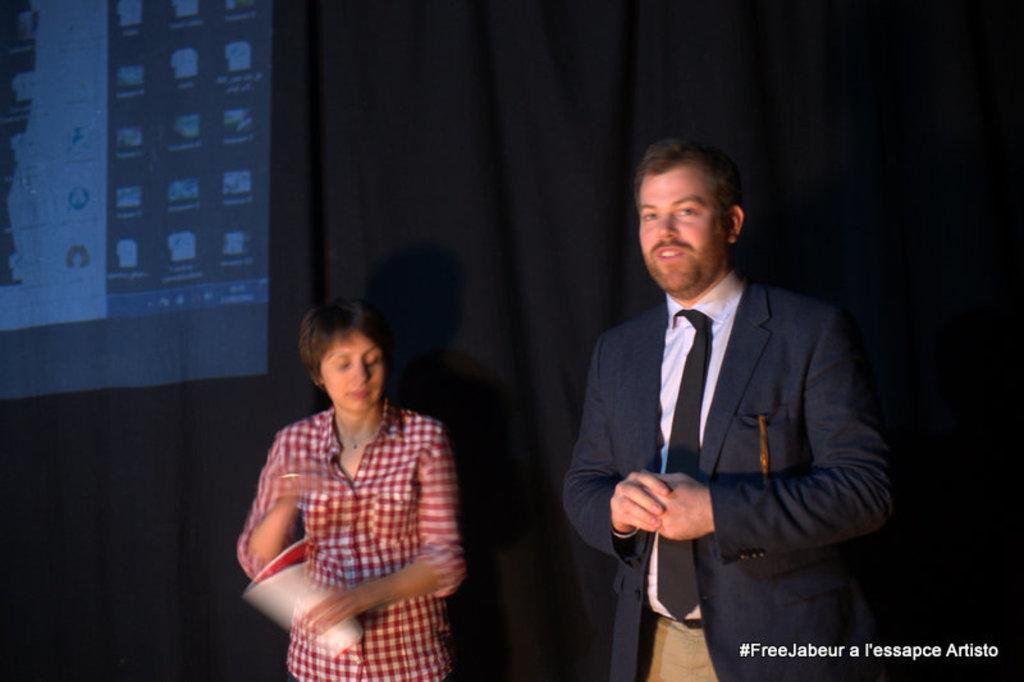Please provide a concise description of this image. In this image we can see two persons, male person wearing suit and female wearing red color shirt standing and in the background of the image there is black color curtain and some video is displaying on it. 